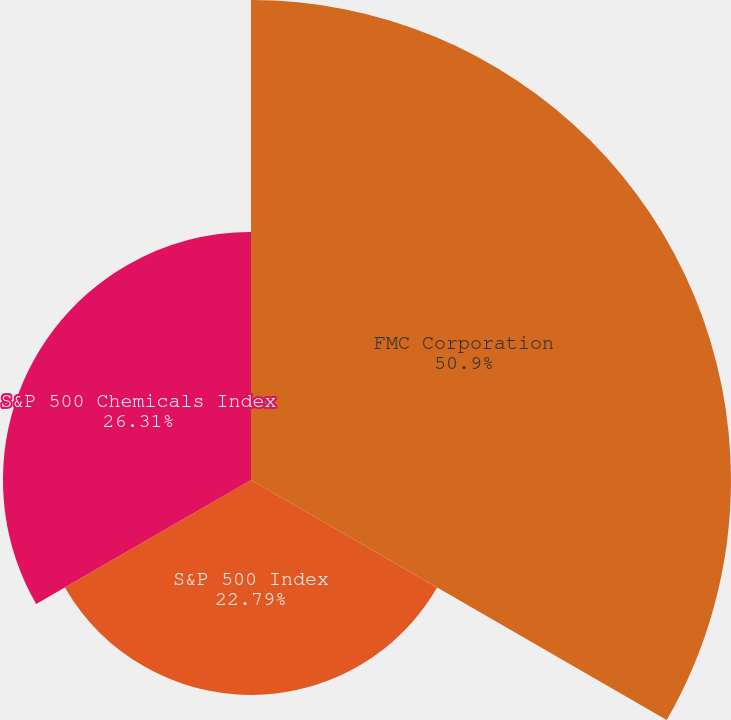<chart> <loc_0><loc_0><loc_500><loc_500><pie_chart><fcel>FMC Corporation<fcel>S&P 500 Index<fcel>S&P 500 Chemicals Index<nl><fcel>50.91%<fcel>22.79%<fcel>26.31%<nl></chart> 